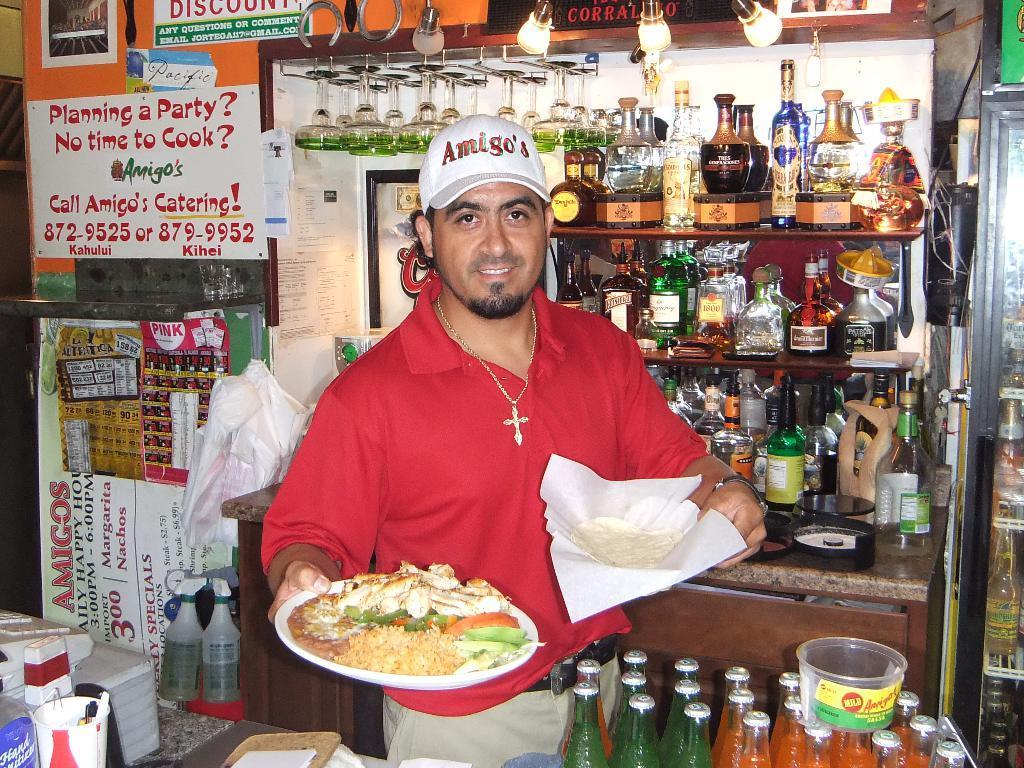Please provide a concise description of this image. In this picture there is a person standing and smiling and he is holding the plates. There is a food on the plate. At the back there are bottles in the cupboard. In the foreground there are bottles and there is a cup, bowl on the table. At the back there are posters on the wall. On the right side of the image there are bottles in the refrigerator. At the top there are lights. 